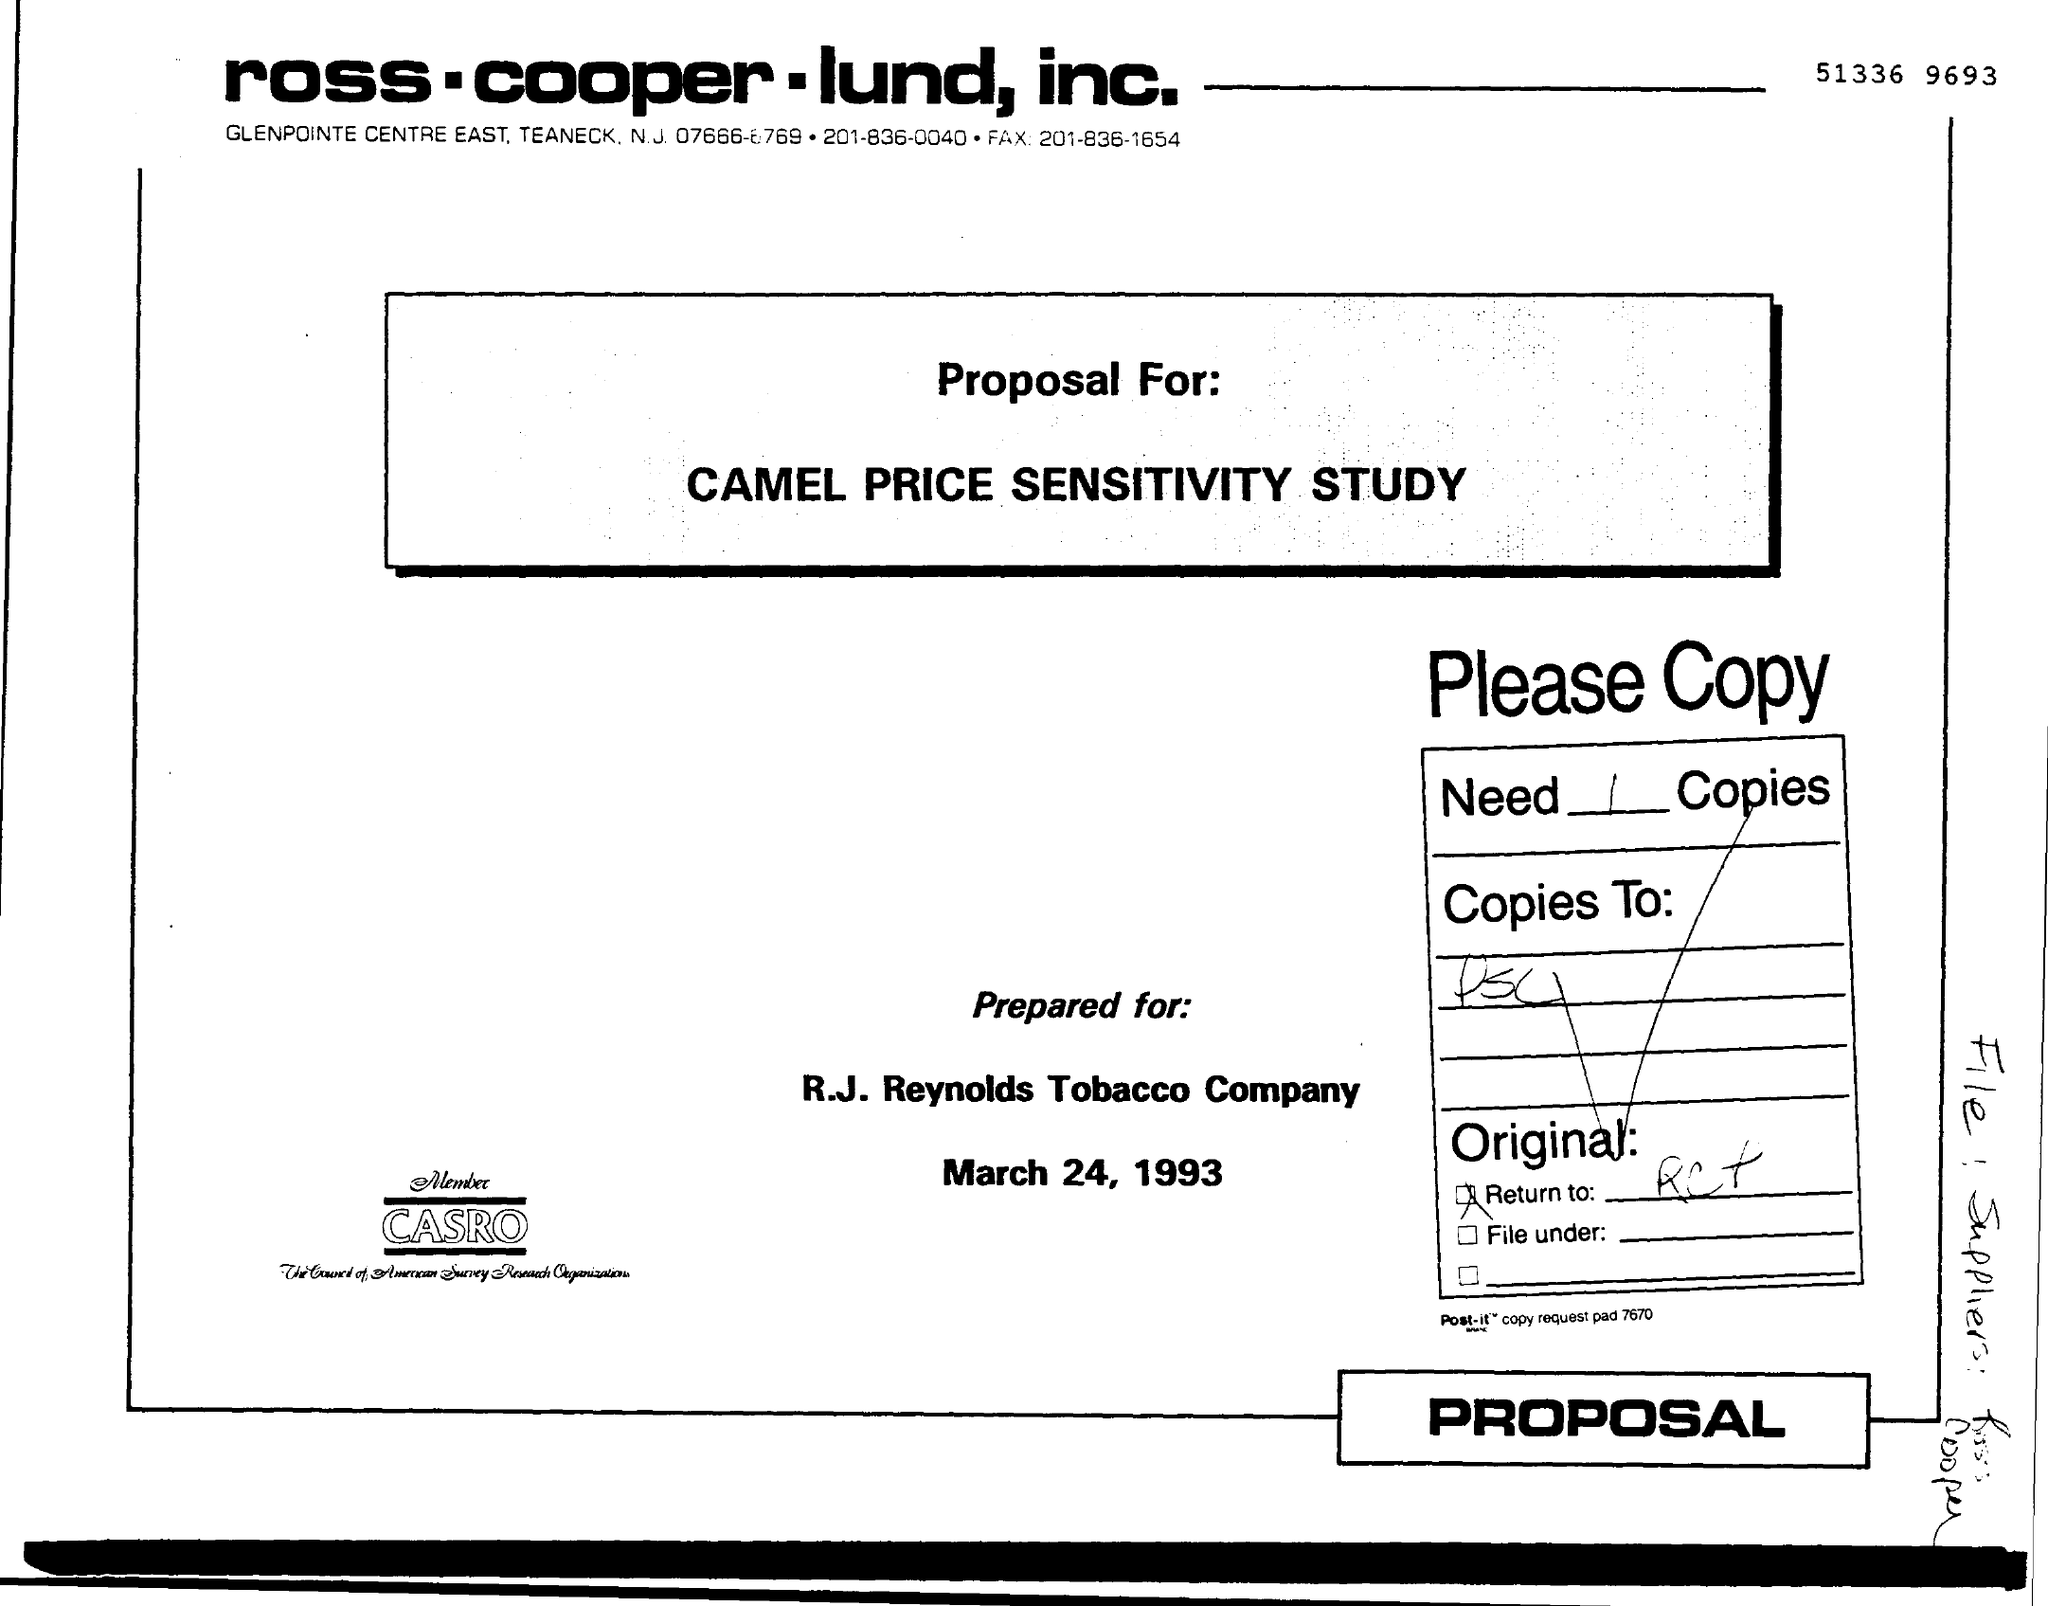Identify some key points in this picture. The date on the document is March 24, 1993. 